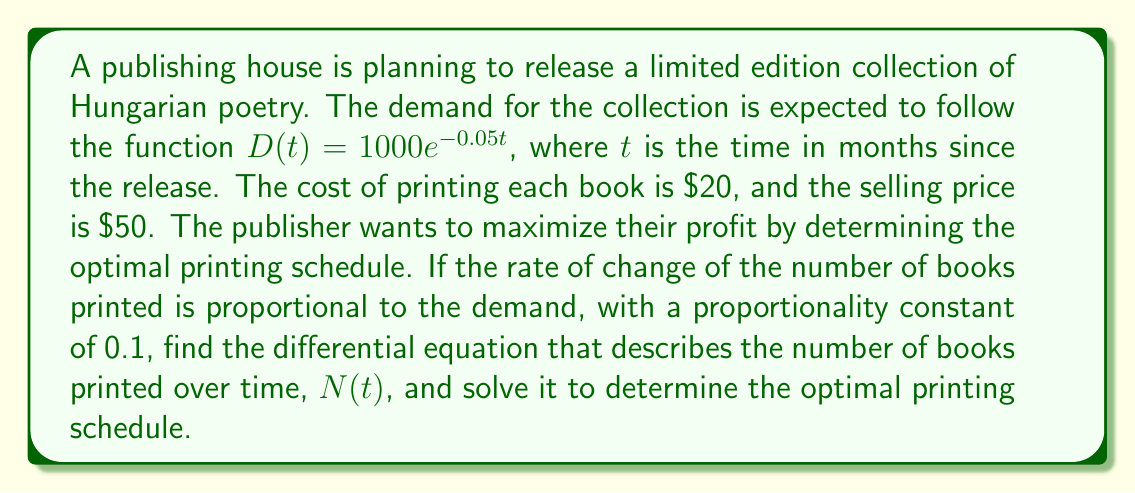Teach me how to tackle this problem. Let's approach this problem step-by-step:

1) First, we need to set up the differential equation. We're told that the rate of change of the number of books printed is proportional to the demand. Mathematically, this can be expressed as:

   $$\frac{dN}{dt} = 0.1 \cdot D(t)$$

2) We're given the demand function $D(t) = 1000e^{-0.05t}$. Substituting this into our equation:

   $$\frac{dN}{dt} = 0.1 \cdot 1000e^{-0.05t} = 100e^{-0.05t}$$

3) This is our differential equation. To solve it, we need to integrate both sides:

   $$\int \frac{dN}{dt} dt = \int 100e^{-0.05t} dt$$

4) The left side integrates to $N$. For the right side, we can use the rule for integrating exponentials:

   $$N = -2000e^{-0.05t} + C$$

   Where $C$ is a constant of integration.

5) To find $C$, we need an initial condition. Let's assume that at $t=0$, no books have been printed yet, so $N(0) = 0$:

   $$0 = -2000e^{-0.05(0)} + C$$
   $$0 = -2000 + C$$
   $$C = 2000$$

6) Therefore, our final solution is:

   $$N(t) = 2000 - 2000e^{-0.05t}$$

This equation describes the optimal number of books to have printed by time $t$.
Answer: The differential equation describing the number of books printed over time is:

$$\frac{dN}{dt} = 100e^{-0.05t}$$

The solution, representing the optimal printing schedule, is:

$$N(t) = 2000 - 2000e^{-0.05t}$$

where $N(t)$ is the cumulative number of books printed by time $t$ (in months). 